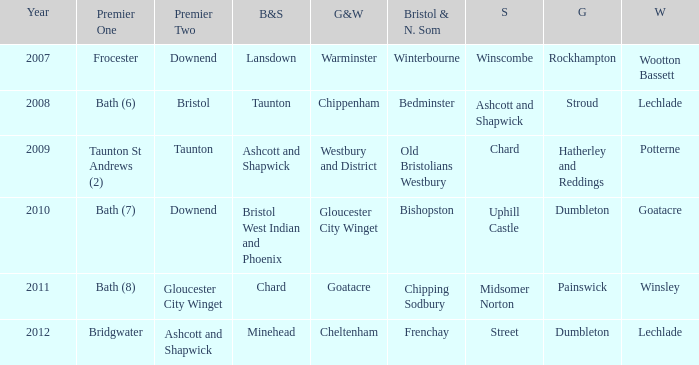What is the year where glos & wilts is gloucester city winget? 2010.0. 